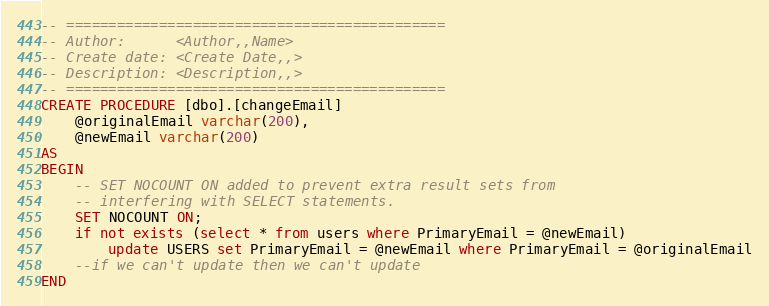Convert code to text. <code><loc_0><loc_0><loc_500><loc_500><_SQL_>-- =============================================
-- Author:		<Author,,Name>
-- Create date: <Create Date,,>
-- Description:	<Description,,>
-- =============================================
CREATE PROCEDURE [dbo].[changeEmail]
	@originalEmail varchar(200),
	@newEmail varchar(200)
AS
BEGIN
	-- SET NOCOUNT ON added to prevent extra result sets from
	-- interfering with SELECT statements.
	SET NOCOUNT ON;
	if not exists (select * from users where PrimaryEmail = @newEmail)
		update USERS set PrimaryEmail = @newEmail where PrimaryEmail = @originalEmail
	--if we can't update then we can't update
END
</code> 